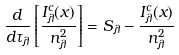Convert formula to latex. <formula><loc_0><loc_0><loc_500><loc_500>\frac { d } { d \tau _ { \lambda } } \left [ \frac { I ^ { c } _ { \lambda } ( x ) } { n ^ { 2 } _ { \lambda } } \right ] = S _ { \lambda } - \frac { I ^ { c } _ { \lambda } ( x ) } { n ^ { 2 } _ { \lambda } }</formula> 